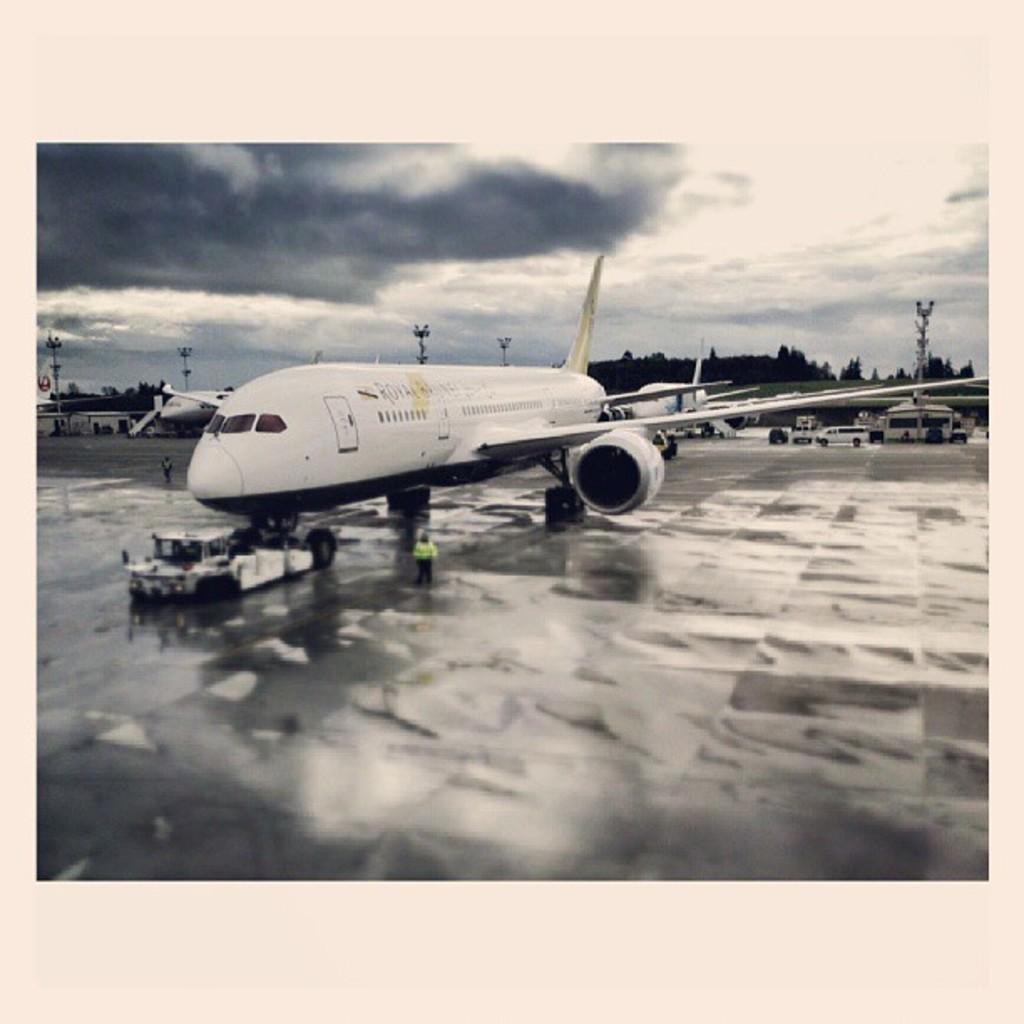Can you describe this image briefly? In the picture I can see a plane which is in white color and there are few objects in front of it and there is a person standing beside it and there are two other planes and some other objects behind it and there are trees and poles in the background and the sky is cloudy. 